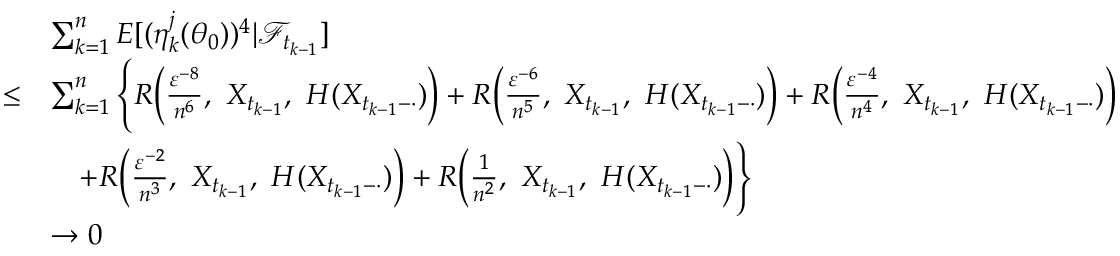<formula> <loc_0><loc_0><loc_500><loc_500>\begin{array} { r l } & { \sum _ { k = 1 } ^ { n } E [ ( \eta _ { k } ^ { j } ( \theta _ { 0 } ) ) ^ { 4 } | \mathcal { F } _ { t _ { k - 1 } } ] } \\ { \leq } & { \sum _ { k = 1 } ^ { n } \left \{ R \left ( \frac { \varepsilon ^ { - 8 } } { n ^ { 6 } } , X _ { t _ { k - 1 } } , H ( X _ { t _ { k - 1 } - \cdot } ) \right ) + R \left ( \frac { \varepsilon ^ { - 6 } } { n ^ { 5 } } , X _ { t _ { k - 1 } } , H ( X _ { t _ { k - 1 } - \cdot } ) \right ) + R \left ( \frac { \varepsilon ^ { - 4 } } { n ^ { 4 } } , X _ { t _ { k - 1 } } , H ( X _ { t _ { k - 1 } - \cdot } ) \right ) } \\ & { \quad + R \left ( \frac { \varepsilon ^ { - 2 } } { n ^ { 3 } } , X _ { t _ { k - 1 } } , H ( X _ { t _ { k - 1 } - \cdot } ) \right ) + R \left ( \frac { 1 } { n ^ { 2 } } , X _ { t _ { k - 1 } } , H ( X _ { t _ { k - 1 } - \cdot } ) \right ) \right \} } \\ & { \rightarrow 0 } \end{array}</formula> 